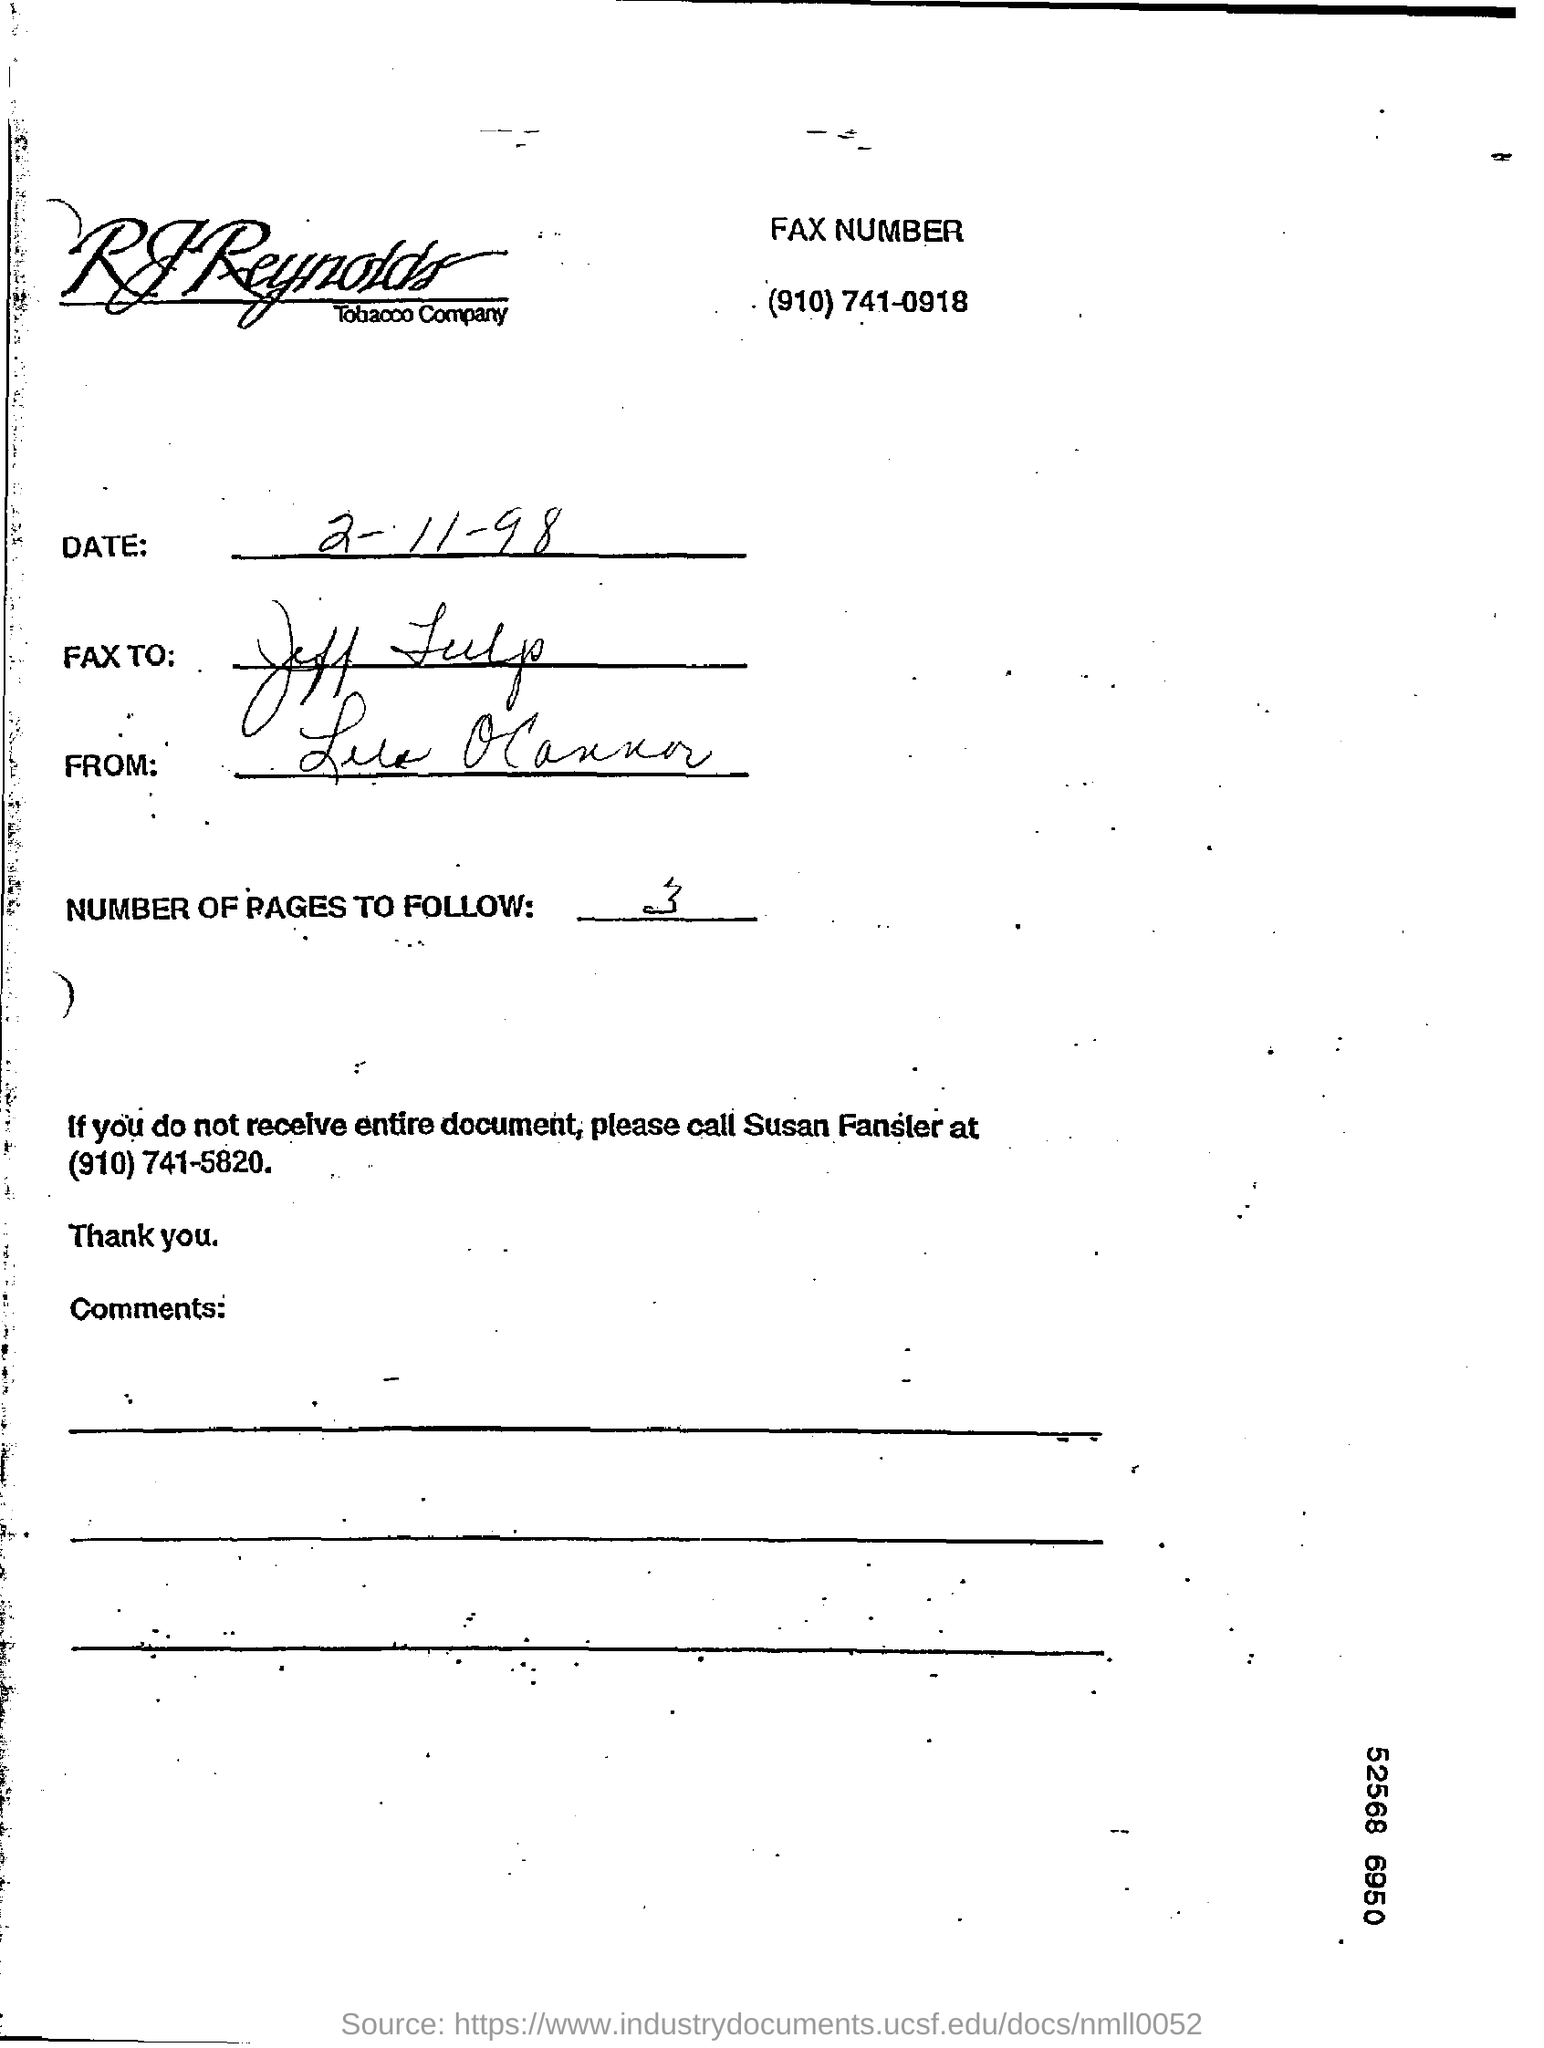Highlight a few significant elements in this photo. The date is February 11, 1998. The number of pages to follow is 3. 